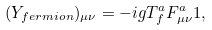Convert formula to latex. <formula><loc_0><loc_0><loc_500><loc_500>( Y _ { f e r m i o n } ) _ { \mu \nu } = - i g T ^ { a } _ { f } F ^ { a } _ { \mu \nu } { 1 } ,</formula> 